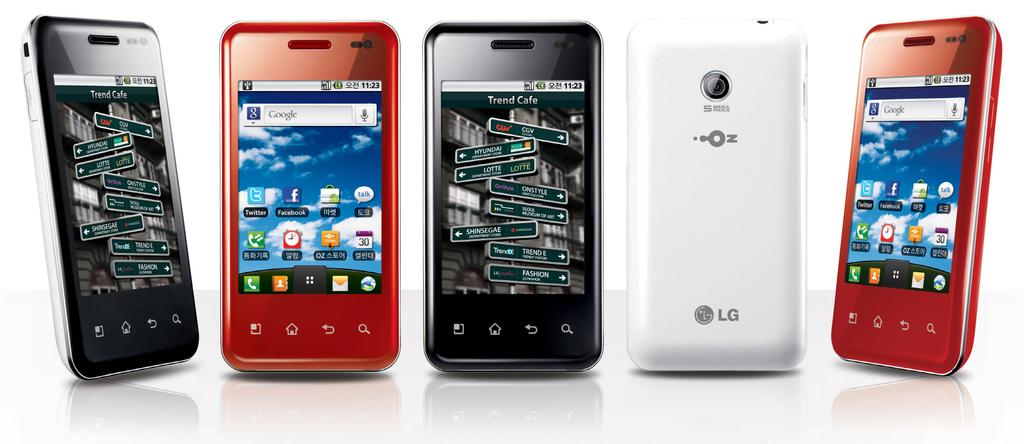<image>
Summarize the visual content of the image. A number of LG phones against a white backdrop. 